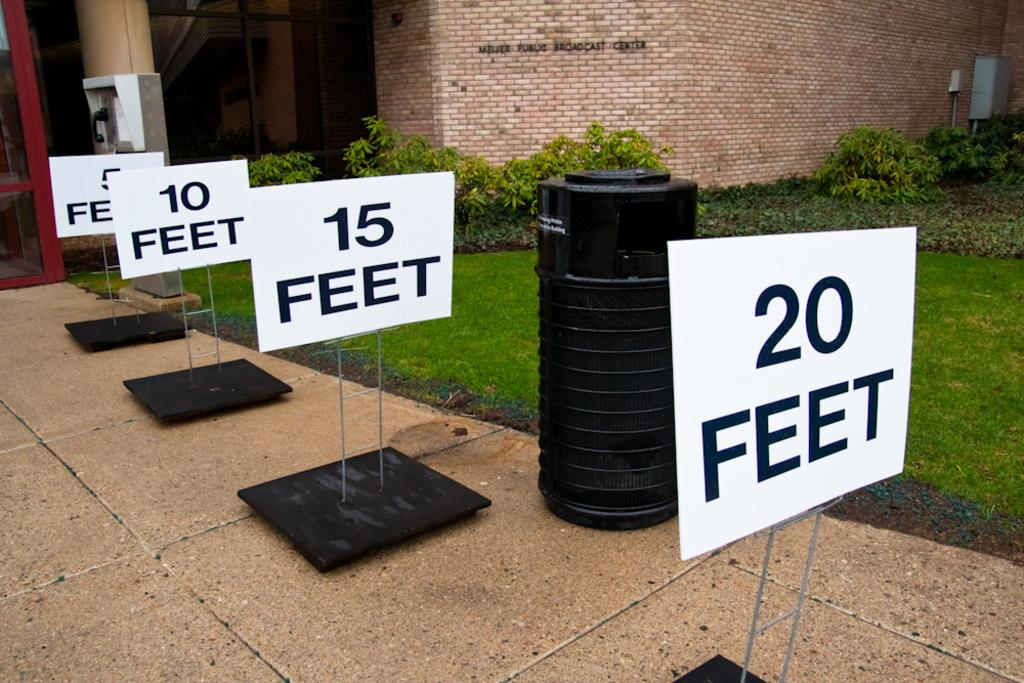<image>
Offer a succinct explanation of the picture presented. four different white signs that read five ten fifteen and twenty feet on them. 